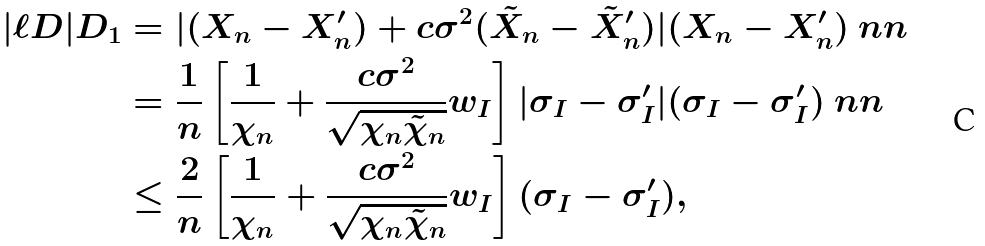<formula> <loc_0><loc_0><loc_500><loc_500>| \ell D | D _ { 1 } & = | ( X _ { n } - X ^ { \prime } _ { n } ) + c \sigma ^ { 2 } ( \tilde { X } _ { n } - \tilde { X } ^ { \prime } _ { n } ) | ( X _ { n } - X ^ { \prime } _ { n } ) \ n n \\ & = \frac { 1 } { n } \left [ \frac { 1 } { \chi _ { n } } + \frac { c \sigma ^ { 2 } } { \sqrt { \chi _ { n } \tilde { \chi } _ { n } } } w _ { I } \right ] | \sigma _ { I } - \sigma ^ { \prime } _ { I } | ( \sigma _ { I } - \sigma ^ { \prime } _ { I } ) \ n n \\ & \leq \frac { 2 } { n } \left [ \frac { 1 } { \chi _ { n } } + \frac { c \sigma ^ { 2 } } { \sqrt { \chi _ { n } \tilde { \chi } _ { n } } } w _ { I } \right ] ( \sigma _ { I } - \sigma ^ { \prime } _ { I } ) ,</formula> 